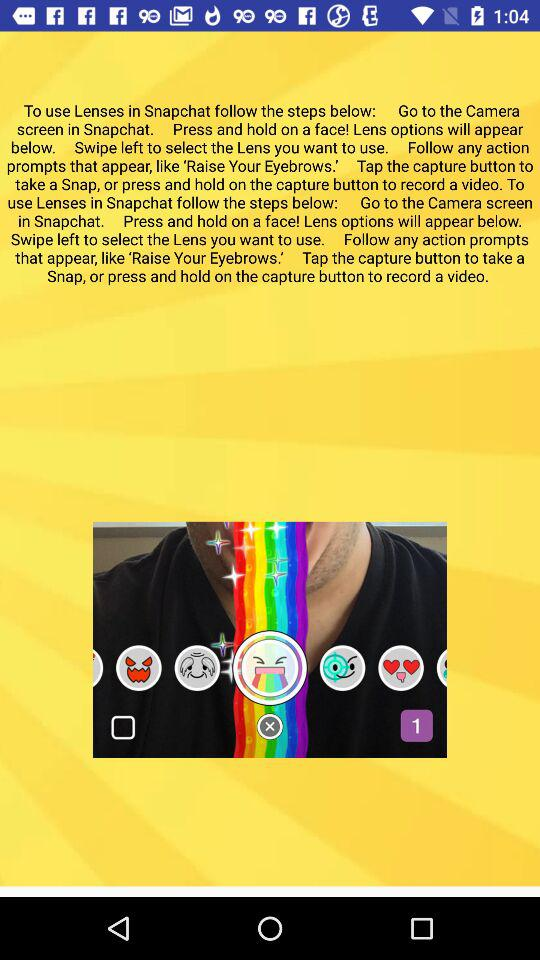What is the application name? The application name is "Snapchat". 